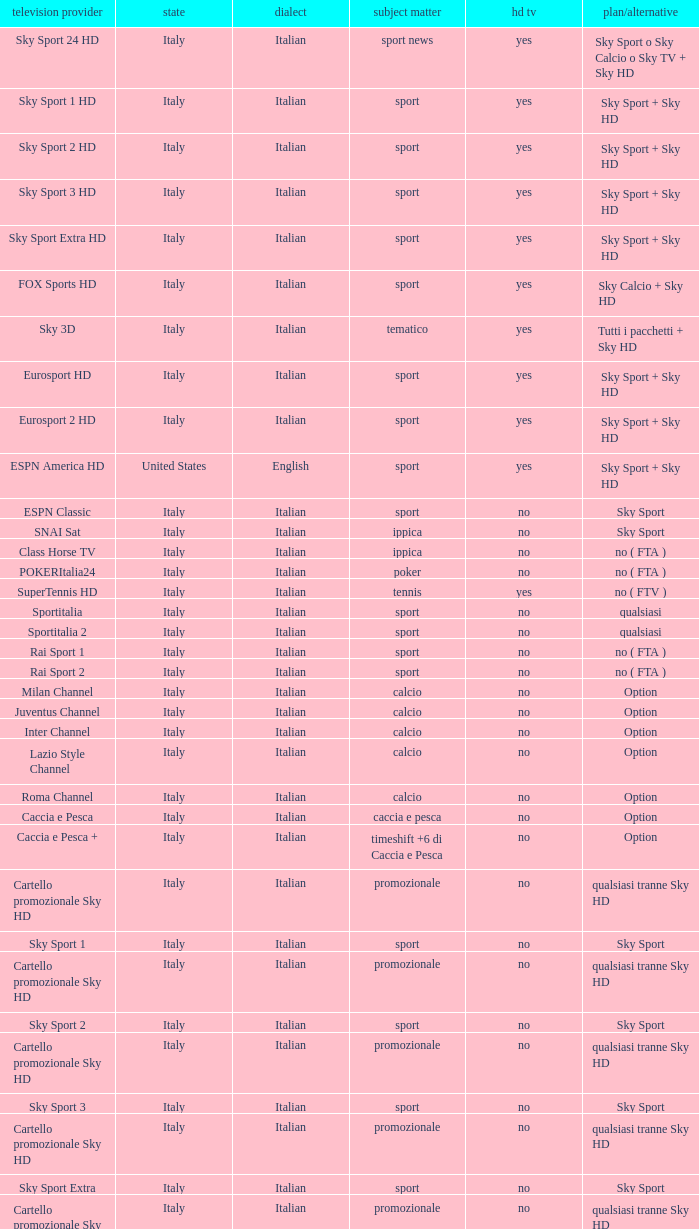Would you mind parsing the complete table? {'header': ['television provider', 'state', 'dialect', 'subject matter', 'hd tv', 'plan/alternative'], 'rows': [['Sky Sport 24 HD', 'Italy', 'Italian', 'sport news', 'yes', 'Sky Sport o Sky Calcio o Sky TV + Sky HD'], ['Sky Sport 1 HD', 'Italy', 'Italian', 'sport', 'yes', 'Sky Sport + Sky HD'], ['Sky Sport 2 HD', 'Italy', 'Italian', 'sport', 'yes', 'Sky Sport + Sky HD'], ['Sky Sport 3 HD', 'Italy', 'Italian', 'sport', 'yes', 'Sky Sport + Sky HD'], ['Sky Sport Extra HD', 'Italy', 'Italian', 'sport', 'yes', 'Sky Sport + Sky HD'], ['FOX Sports HD', 'Italy', 'Italian', 'sport', 'yes', 'Sky Calcio + Sky HD'], ['Sky 3D', 'Italy', 'Italian', 'tematico', 'yes', 'Tutti i pacchetti + Sky HD'], ['Eurosport HD', 'Italy', 'Italian', 'sport', 'yes', 'Sky Sport + Sky HD'], ['Eurosport 2 HD', 'Italy', 'Italian', 'sport', 'yes', 'Sky Sport + Sky HD'], ['ESPN America HD', 'United States', 'English', 'sport', 'yes', 'Sky Sport + Sky HD'], ['ESPN Classic', 'Italy', 'Italian', 'sport', 'no', 'Sky Sport'], ['SNAI Sat', 'Italy', 'Italian', 'ippica', 'no', 'Sky Sport'], ['Class Horse TV', 'Italy', 'Italian', 'ippica', 'no', 'no ( FTA )'], ['POKERItalia24', 'Italy', 'Italian', 'poker', 'no', 'no ( FTA )'], ['SuperTennis HD', 'Italy', 'Italian', 'tennis', 'yes', 'no ( FTV )'], ['Sportitalia', 'Italy', 'Italian', 'sport', 'no', 'qualsiasi'], ['Sportitalia 2', 'Italy', 'Italian', 'sport', 'no', 'qualsiasi'], ['Rai Sport 1', 'Italy', 'Italian', 'sport', 'no', 'no ( FTA )'], ['Rai Sport 2', 'Italy', 'Italian', 'sport', 'no', 'no ( FTA )'], ['Milan Channel', 'Italy', 'Italian', 'calcio', 'no', 'Option'], ['Juventus Channel', 'Italy', 'Italian', 'calcio', 'no', 'Option'], ['Inter Channel', 'Italy', 'Italian', 'calcio', 'no', 'Option'], ['Lazio Style Channel', 'Italy', 'Italian', 'calcio', 'no', 'Option'], ['Roma Channel', 'Italy', 'Italian', 'calcio', 'no', 'Option'], ['Caccia e Pesca', 'Italy', 'Italian', 'caccia e pesca', 'no', 'Option'], ['Caccia e Pesca +', 'Italy', 'Italian', 'timeshift +6 di Caccia e Pesca', 'no', 'Option'], ['Cartello promozionale Sky HD', 'Italy', 'Italian', 'promozionale', 'no', 'qualsiasi tranne Sky HD'], ['Sky Sport 1', 'Italy', 'Italian', 'sport', 'no', 'Sky Sport'], ['Cartello promozionale Sky HD', 'Italy', 'Italian', 'promozionale', 'no', 'qualsiasi tranne Sky HD'], ['Sky Sport 2', 'Italy', 'Italian', 'sport', 'no', 'Sky Sport'], ['Cartello promozionale Sky HD', 'Italy', 'Italian', 'promozionale', 'no', 'qualsiasi tranne Sky HD'], ['Sky Sport 3', 'Italy', 'Italian', 'sport', 'no', 'Sky Sport'], ['Cartello promozionale Sky HD', 'Italy', 'Italian', 'promozionale', 'no', 'qualsiasi tranne Sky HD'], ['Sky Sport Extra', 'Italy', 'Italian', 'sport', 'no', 'Sky Sport'], ['Cartello promozionale Sky HD', 'Italy', 'Italian', 'promozionale', 'no', 'qualsiasi tranne Sky HD'], ['Sky Supercalcio', 'Italy', 'Italian', 'calcio', 'no', 'Sky Calcio'], ['Cartello promozionale Sky HD', 'Italy', 'Italian', 'promozionale', 'no', 'qualsiasi tranne Sky HD'], ['Eurosport', 'Italy', 'Italian', 'sport', 'no', 'Sky Sport'], ['Eurosport 2', 'Italy', 'Italian', 'sport', 'no', 'Sky Sport'], ['ESPN America', 'Italy', 'Italian', 'sport', 'no', 'Sky Sport']]} What is Package/Option, when Content is Poker? No ( fta ). 